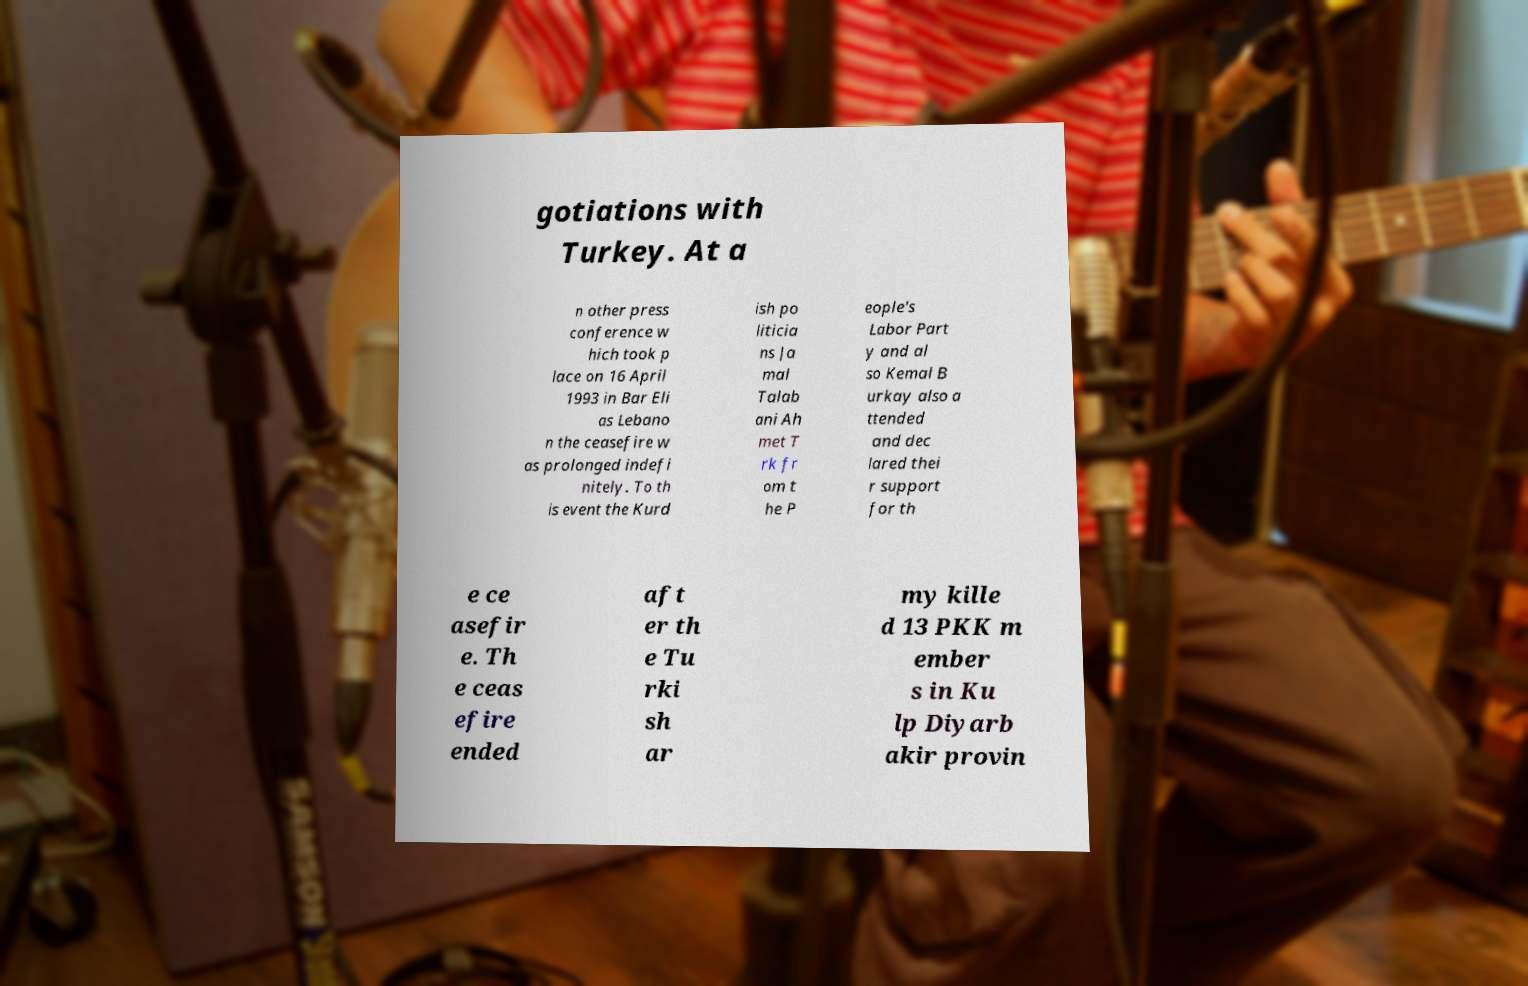Could you assist in decoding the text presented in this image and type it out clearly? gotiations with Turkey. At a n other press conference w hich took p lace on 16 April 1993 in Bar Eli as Lebano n the ceasefire w as prolonged indefi nitely. To th is event the Kurd ish po liticia ns Ja mal Talab ani Ah met T rk fr om t he P eople's Labor Part y and al so Kemal B urkay also a ttended and dec lared thei r support for th e ce asefir e. Th e ceas efire ended aft er th e Tu rki sh ar my kille d 13 PKK m ember s in Ku lp Diyarb akir provin 